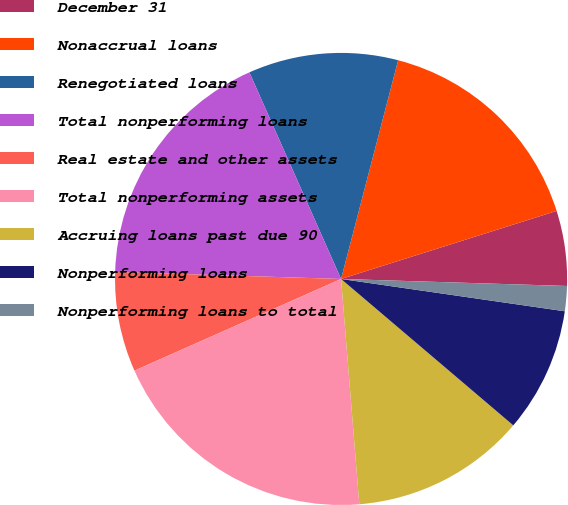Convert chart to OTSL. <chart><loc_0><loc_0><loc_500><loc_500><pie_chart><fcel>December 31<fcel>Nonaccrual loans<fcel>Renegotiated loans<fcel>Total nonperforming loans<fcel>Real estate and other assets<fcel>Total nonperforming assets<fcel>Accruing loans past due 90<fcel>Nonperforming loans<fcel>Nonperforming loans to total<nl><fcel>5.36%<fcel>16.07%<fcel>10.71%<fcel>17.86%<fcel>7.14%<fcel>19.64%<fcel>12.5%<fcel>8.93%<fcel>1.79%<nl></chart> 